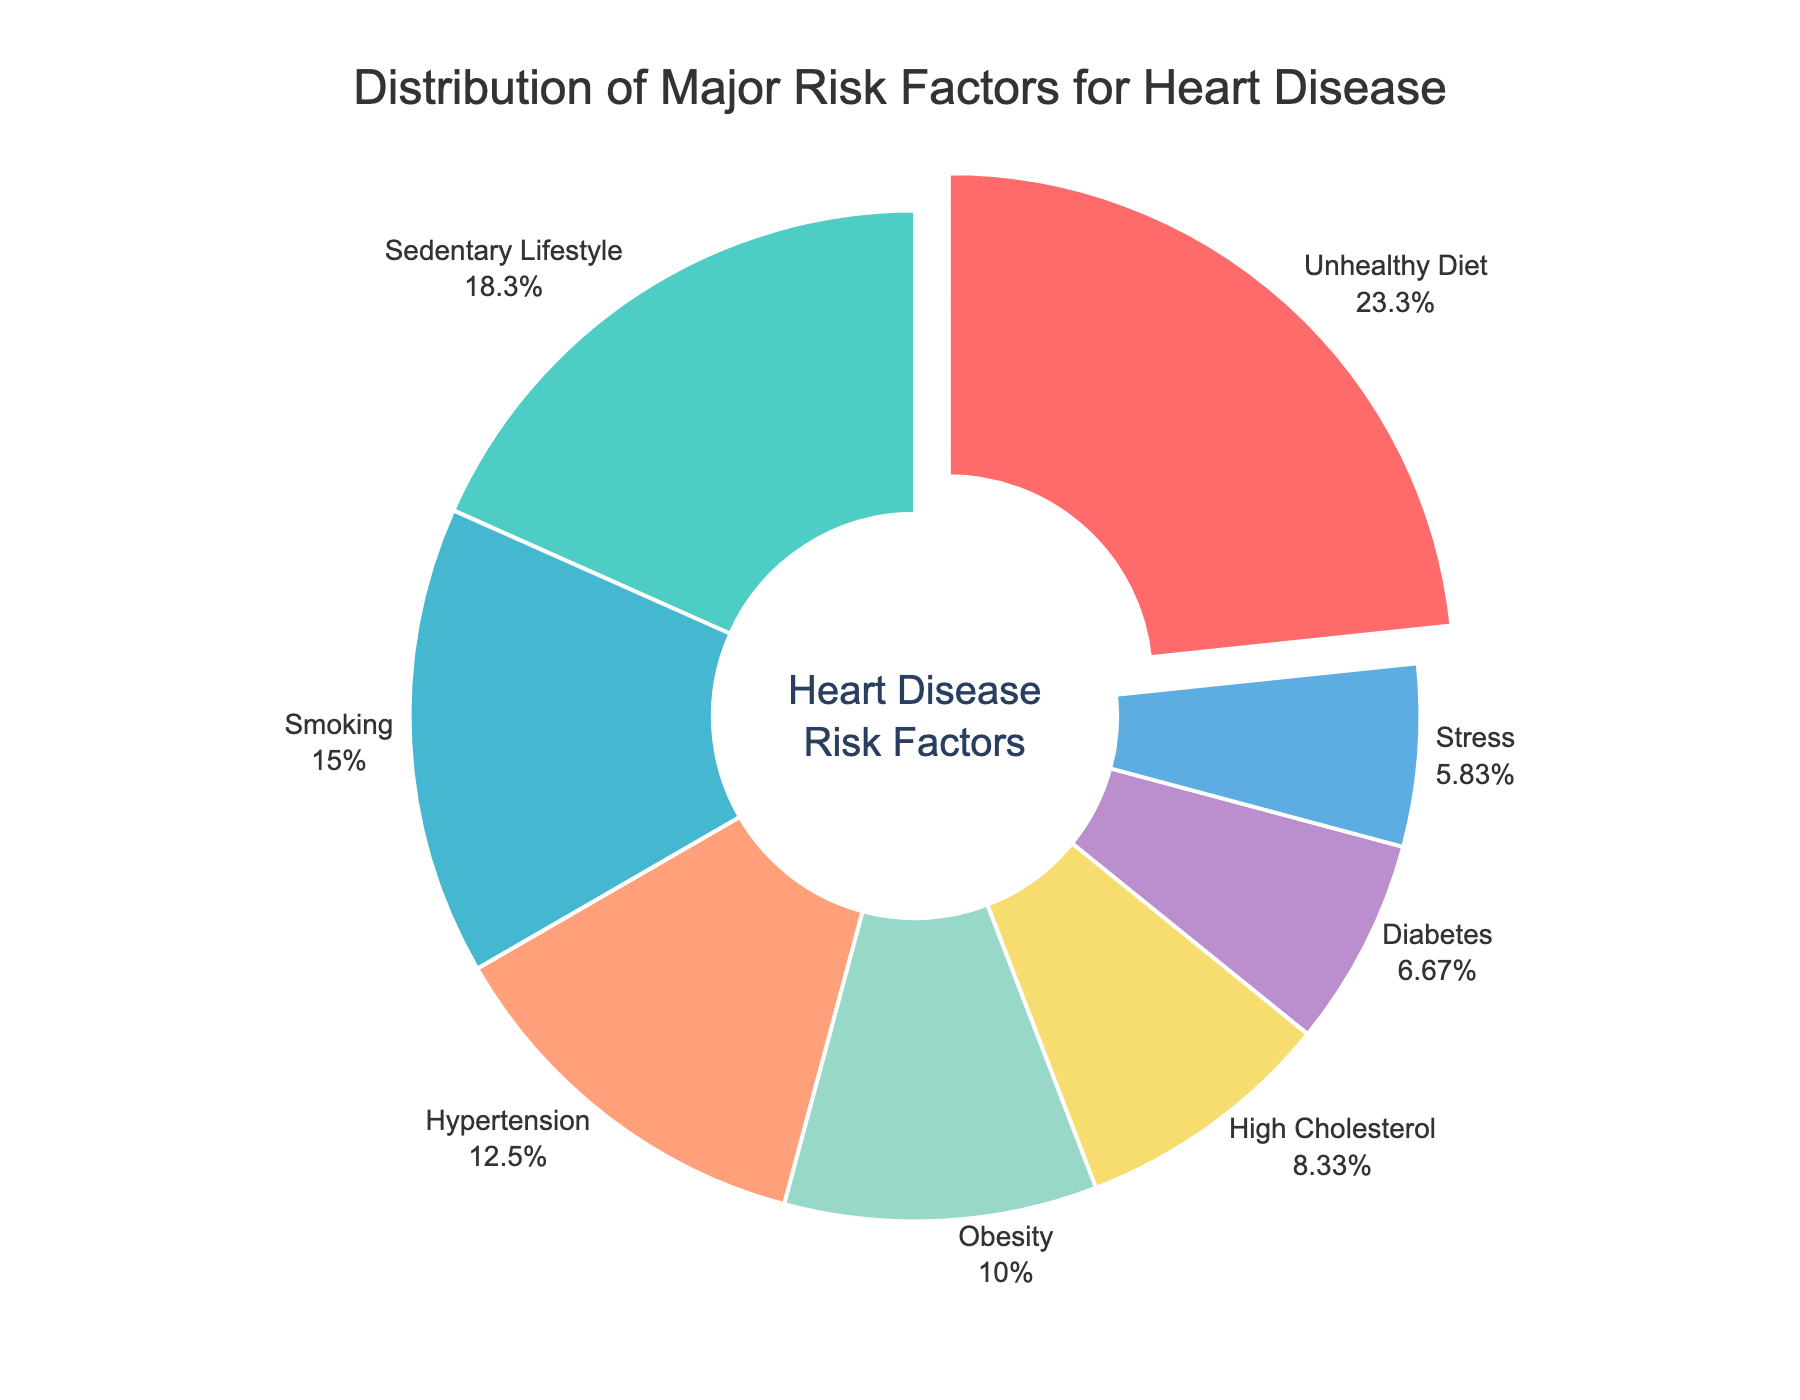Which risk factor has the highest percentage? The figure shows the distribution of risk factors, each with a percentage. The highest percentage is indicated next to "Unhealthy Diet" which is 28%.
Answer: Unhealthy Diet What is the total percentage of Sedentary Lifestyle and Smoking combined? To find the total, add the percentages of Sedentary Lifestyle (22%) and Smoking (18%). The sum is 22 + 18 = 40%.
Answer: 40% Among Hypertension, Obesity, and High Cholesterol, which has the lowest percentage? The figure lists the percentages for Hypertension (15%), Obesity (12%), and High Cholesterol (10%). The lowest value of these three is High Cholesterol at 10%.
Answer: High Cholesterol Is the percentage of Stress greater or less than that of Diabetes? The figure shows the percentage of Stress as 7% and Diabetes as 8%. Comparing these two values, 7% for Stress is less than 8% for Diabetes.
Answer: Less How many risk factors have a percentage greater than or equal to 15%? The risk factors with their percentages: Unhealthy Diet (28%), Sedentary Lifestyle (22%), Smoking (18%), and Hypertension (15%) all have percentages that are greater than or equal to 15%. Therefore, there are 4 such factors.
Answer: 4 Calculate the difference in percentages between the highest and lowest risk factors. Identify the highest percentage (Unhealthy Diet at 28%) and the lowest percentage (Stress at 7%). The difference is calculated as 28 - 7 = 21.
Answer: 21 Which risk factor is represented in green, and what’s its percentage? In the visual, Sedentary Lifestyle is represented by the green color, and its percentage is 22%.
Answer: Sedentary Lifestyle, 22% Are Hypertension and Obesity combined greater than Smoking alone? The percentages for Hypertension (15%), Obesity (12%), and Smoking (18%) are provided. Sum Hypertension and Obesity which is 15 + 12 = 27%. Compare this with Smoking which is 18%. Hence, 27% is greater than 18%.
Answer: Yes If Diabetes and High Cholesterol are combined, what portion of the pie chart do they cover? The percentages for Diabetes and High Cholesterol are 8% and 10%, respectively. Combining these two gives 8 + 10 = 18%.
Answer: 18% Which risk factors are represented by distinct color shades of red? The visual shows that Unhealthy Diet is marked with a vibrant red, and Smoking with a lighter red hue. Their corresponding percentages are 28% and 18%.
Answer: Unhealthy Diet and Smoking 